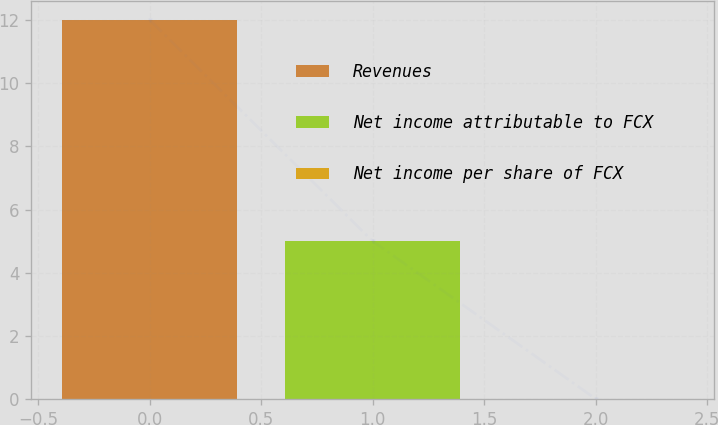Convert chart. <chart><loc_0><loc_0><loc_500><loc_500><bar_chart><fcel>Revenues<fcel>Net income attributable to FCX<fcel>Net income per share of FCX<nl><fcel>12<fcel>5<fcel>0.01<nl></chart> 